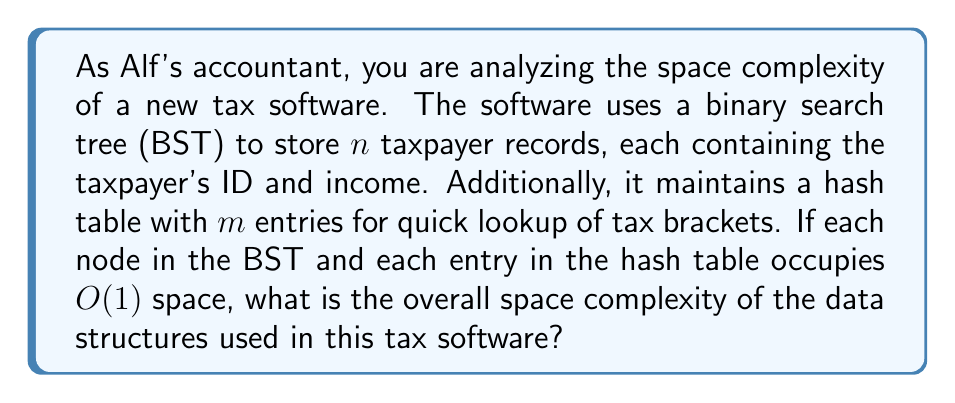Give your solution to this math problem. To determine the overall space complexity, we need to analyze the space requirements of both data structures:

1. Binary Search Tree (BST):
   - The BST stores $n$ taxpayer records.
   - Each node in the BST contains a taxpayer's ID, income, and two pointers (left and right child).
   - Since each node occupies $O(1)$ space, the total space complexity for the BST is $O(n)$.

2. Hash Table:
   - The hash table has $m$ entries for tax brackets.
   - Each entry in the hash table occupies $O(1)$ space.
   - The total space complexity for the hash table is $O(m)$.

To calculate the overall space complexity, we need to combine these two:

$$\text{Total Space Complexity} = O(n) + O(m)$$

In Big O notation, we typically express the complexity in terms of the dominant factor. However, since $n$ and $m$ are independent variables (the number of taxpayers doesn't necessarily correlate with the number of tax brackets), we cannot simplify this further.

Therefore, the overall space complexity remains $O(n + m)$.
Answer: $O(n + m)$, where $n$ is the number of taxpayer records and $m$ is the number of tax bracket entries. 